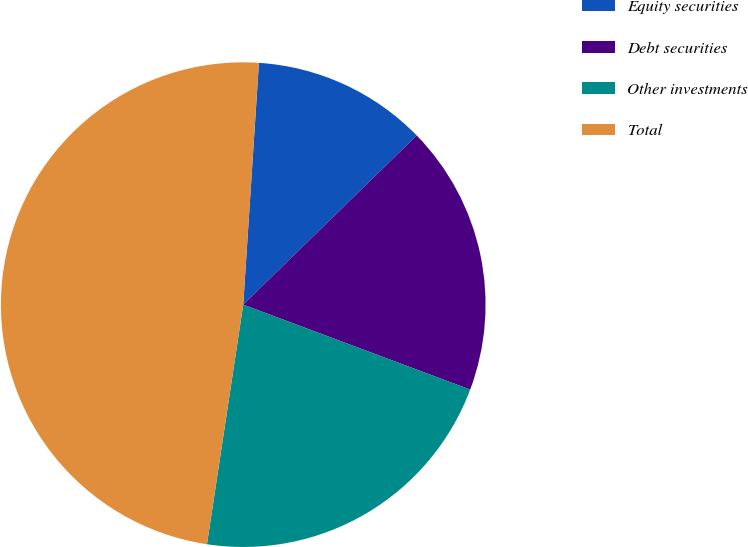Convert chart. <chart><loc_0><loc_0><loc_500><loc_500><pie_chart><fcel>Equity securities<fcel>Debt securities<fcel>Other investments<fcel>Total<nl><fcel>11.67%<fcel>18.0%<fcel>21.69%<fcel>48.64%<nl></chart> 